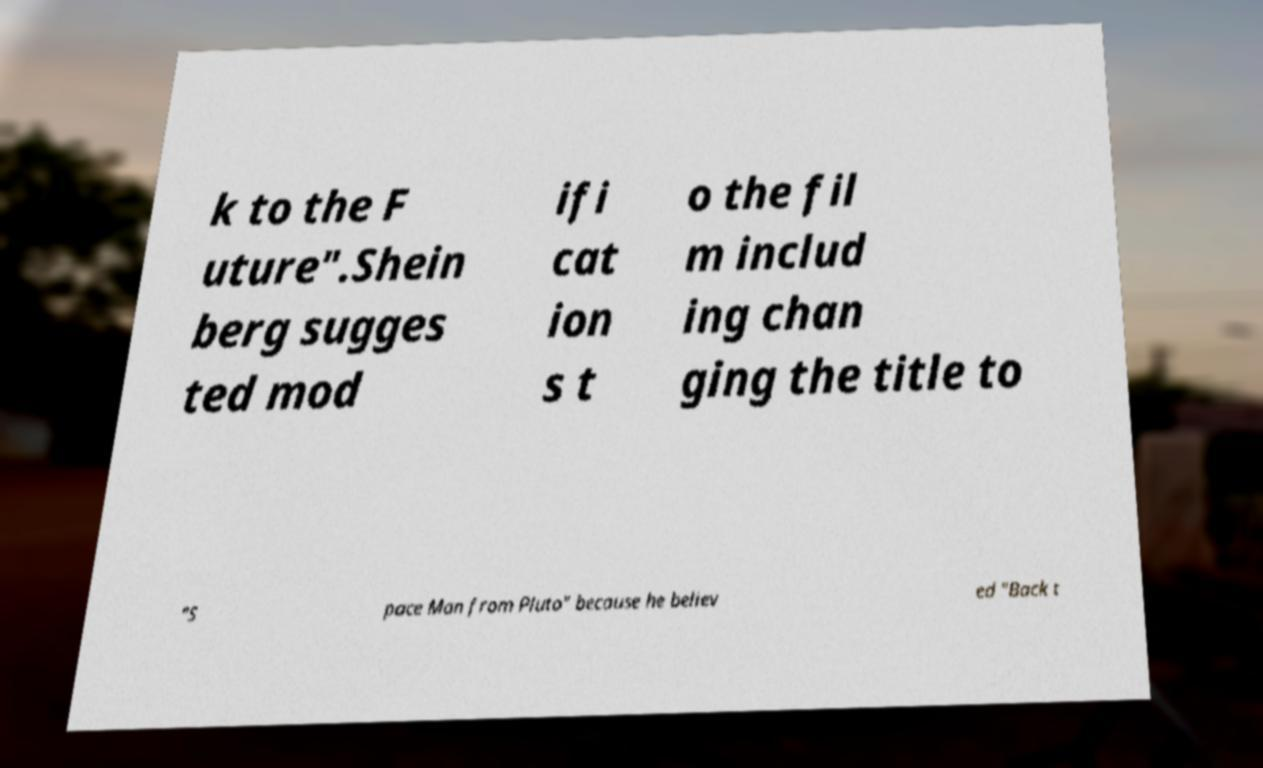For documentation purposes, I need the text within this image transcribed. Could you provide that? k to the F uture".Shein berg sugges ted mod ifi cat ion s t o the fil m includ ing chan ging the title to "S pace Man from Pluto" because he believ ed "Back t 